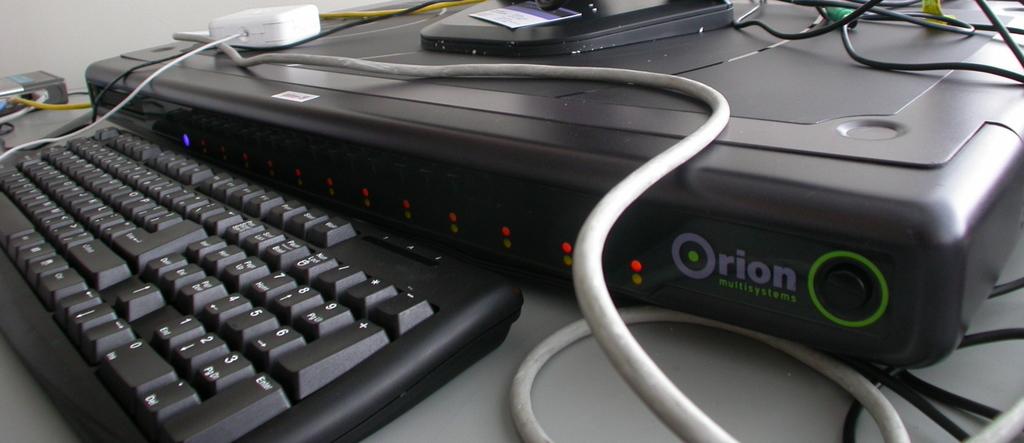What brand of computing device is shown?
Your answer should be compact. Orion. Is there an "enter" key on the keyboard?
Give a very brief answer. Yes. 